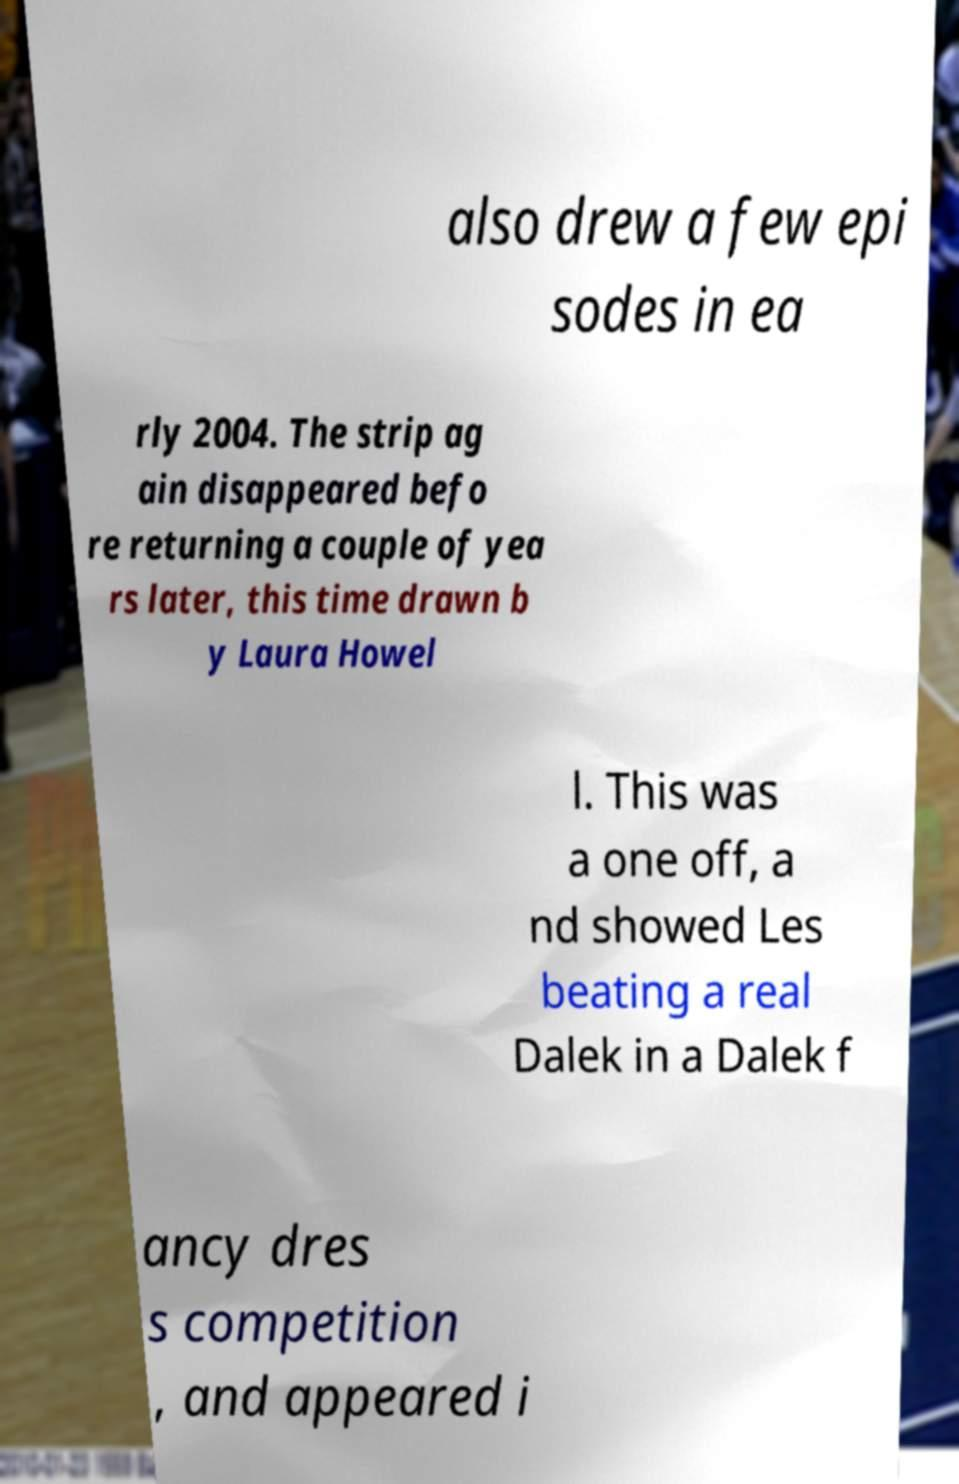I need the written content from this picture converted into text. Can you do that? also drew a few epi sodes in ea rly 2004. The strip ag ain disappeared befo re returning a couple of yea rs later, this time drawn b y Laura Howel l. This was a one off, a nd showed Les beating a real Dalek in a Dalek f ancy dres s competition , and appeared i 